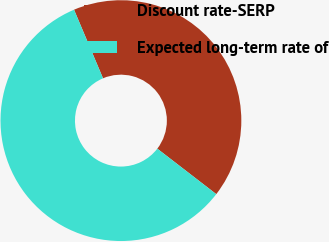<chart> <loc_0><loc_0><loc_500><loc_500><pie_chart><fcel>Discount rate-SERP<fcel>Expected long-term rate of<nl><fcel>41.82%<fcel>58.18%<nl></chart> 